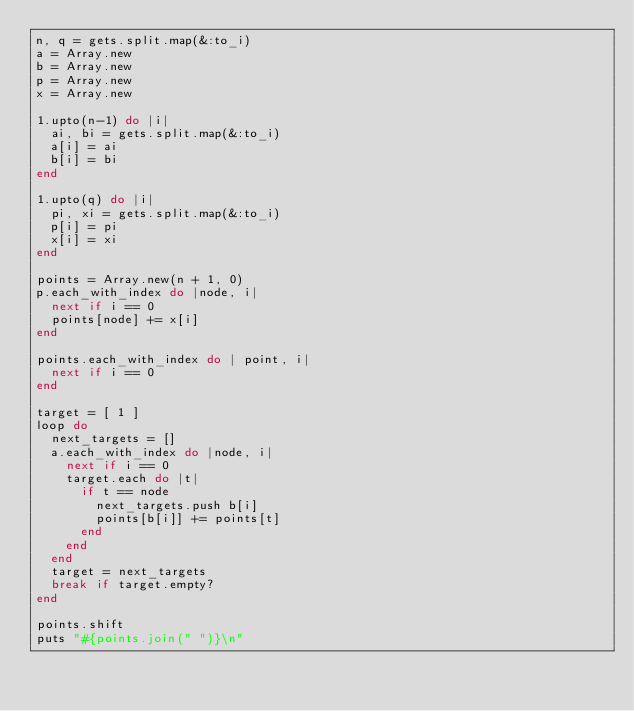Convert code to text. <code><loc_0><loc_0><loc_500><loc_500><_Ruby_>n, q = gets.split.map(&:to_i)
a = Array.new
b = Array.new
p = Array.new
x = Array.new

1.upto(n-1) do |i|
  ai, bi = gets.split.map(&:to_i)
  a[i] = ai
  b[i] = bi
end

1.upto(q) do |i|
  pi, xi = gets.split.map(&:to_i)
  p[i] = pi
  x[i] = xi
end

points = Array.new(n + 1, 0)
p.each_with_index do |node, i|
  next if i == 0
  points[node] += x[i]
end

points.each_with_index do | point, i|
  next if i == 0
end

target = [ 1 ]
loop do
  next_targets = []
  a.each_with_index do |node, i|
    next if i == 0
    target.each do |t|
      if t == node
        next_targets.push b[i]
        points[b[i]] += points[t]
      end
    end
  end
  target = next_targets
  break if target.empty?
end

points.shift
puts "#{points.join(" ")}\n"
</code> 